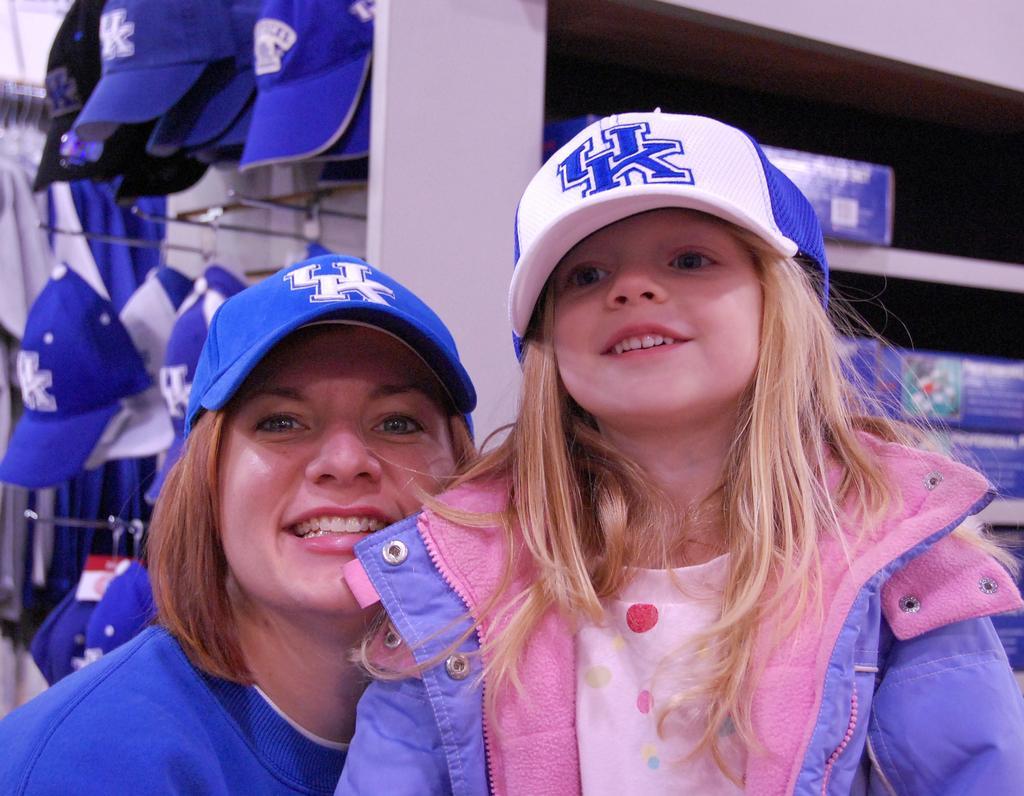Please provide a concise description of this image. In this picture I can see a woman and a girl wearing caps on their heads and in the back I can see few caps to the stand and few boxes on the shelves. 